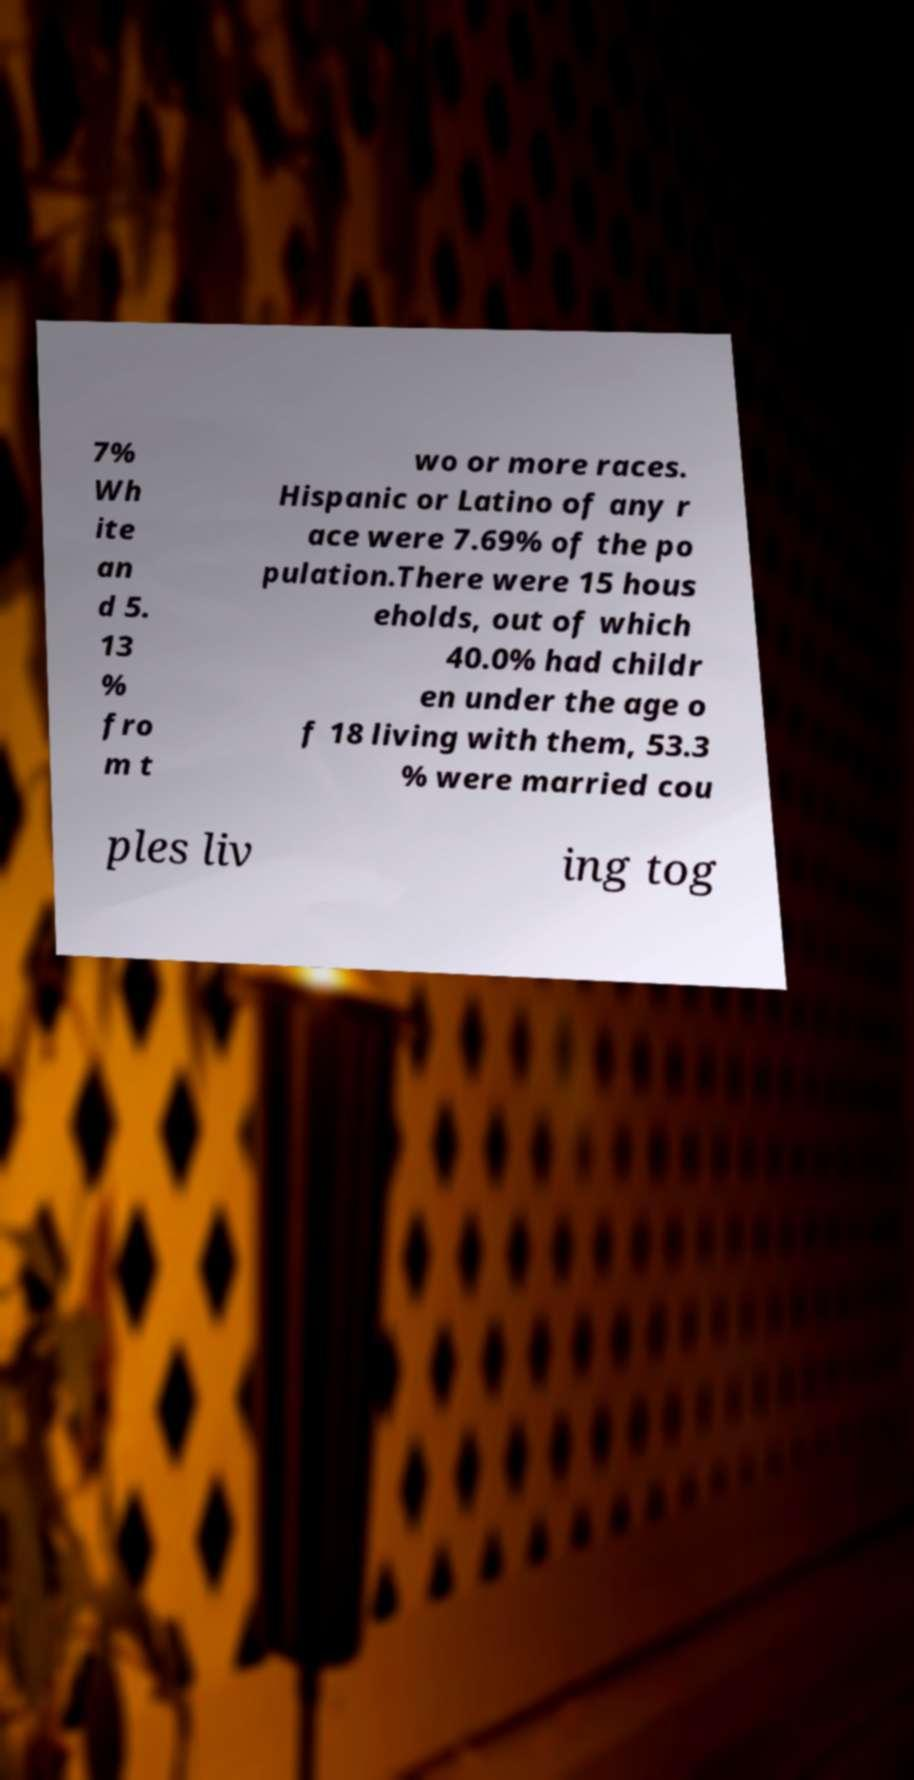Please identify and transcribe the text found in this image. 7% Wh ite an d 5. 13 % fro m t wo or more races. Hispanic or Latino of any r ace were 7.69% of the po pulation.There were 15 hous eholds, out of which 40.0% had childr en under the age o f 18 living with them, 53.3 % were married cou ples liv ing tog 